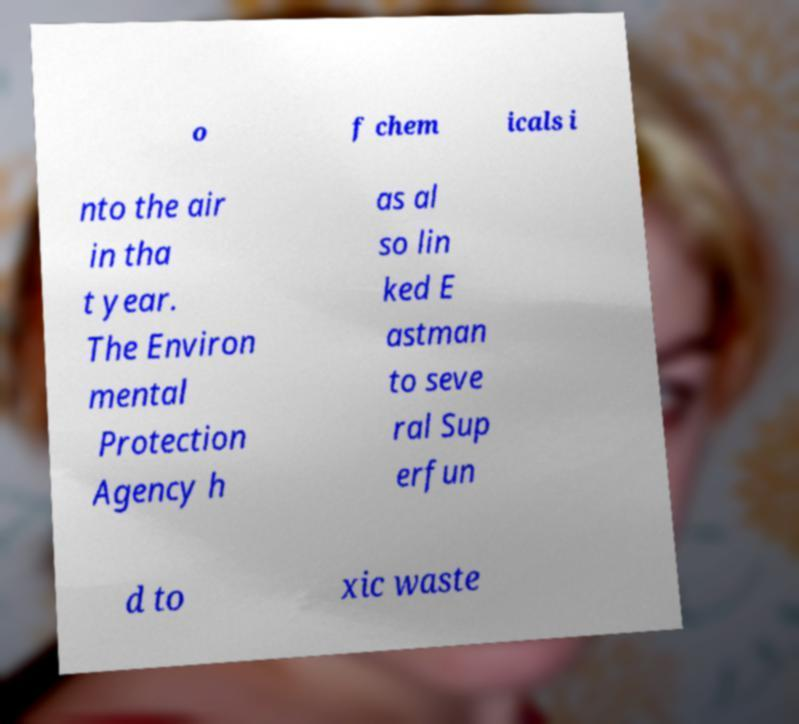I need the written content from this picture converted into text. Can you do that? o f chem icals i nto the air in tha t year. The Environ mental Protection Agency h as al so lin ked E astman to seve ral Sup erfun d to xic waste 